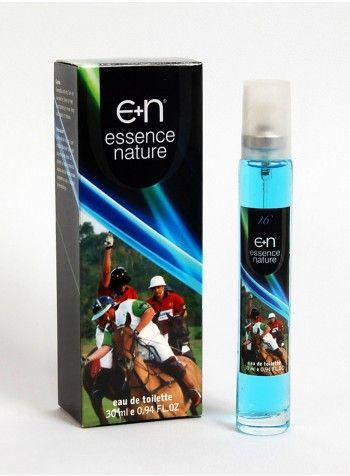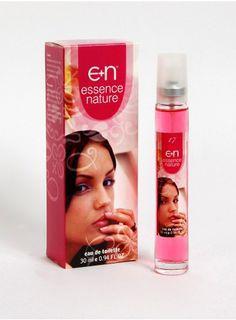The first image is the image on the left, the second image is the image on the right. Analyze the images presented: Is the assertion "Both images shows a perfume box with a human being on it." valid? Answer yes or no. Yes. The first image is the image on the left, the second image is the image on the right. Considering the images on both sides, is "A young woman is featured on the front of the bottle." valid? Answer yes or no. Yes. 